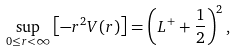<formula> <loc_0><loc_0><loc_500><loc_500>\sup _ { 0 \leq r < \infty } \left [ - r ^ { 2 } V ( r ) \right ] = \left ( L ^ { + } + \frac { 1 } { 2 } \right ) ^ { 2 } ,</formula> 